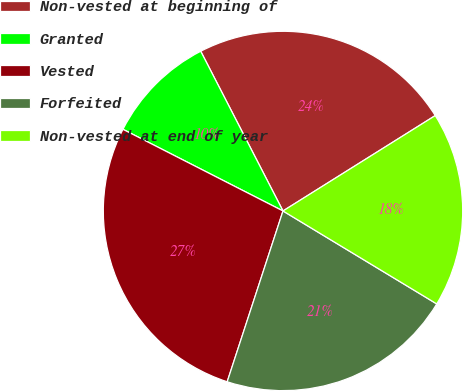<chart> <loc_0><loc_0><loc_500><loc_500><pie_chart><fcel>Non-vested at beginning of<fcel>Granted<fcel>Vested<fcel>Forfeited<fcel>Non-vested at end of year<nl><fcel>23.66%<fcel>9.92%<fcel>27.48%<fcel>21.37%<fcel>17.56%<nl></chart> 